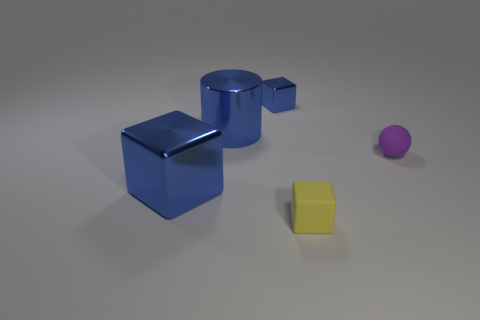Subtract all tiny cubes. How many cubes are left? 1 Subtract all blue cubes. How many cubes are left? 1 Add 3 tiny cubes. How many objects exist? 8 Subtract 1 cylinders. How many cylinders are left? 0 Subtract all spheres. How many objects are left? 4 Subtract 0 red blocks. How many objects are left? 5 Subtract all cyan balls. Subtract all blue cylinders. How many balls are left? 1 Subtract all blue cubes. How many gray spheres are left? 0 Subtract all tiny yellow objects. Subtract all small blue rubber spheres. How many objects are left? 4 Add 1 small metallic objects. How many small metallic objects are left? 2 